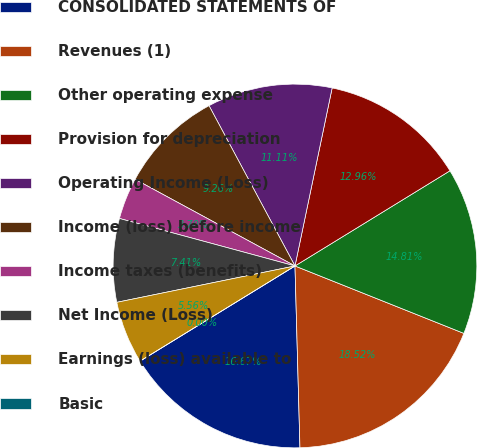<chart> <loc_0><loc_0><loc_500><loc_500><pie_chart><fcel>CONSOLIDATED STATEMENTS OF<fcel>Revenues (1)<fcel>Other operating expense<fcel>Provision for depreciation<fcel>Operating Income (Loss)<fcel>Income (loss) before income<fcel>Income taxes (benefits)<fcel>Net Income (Loss)<fcel>Earnings (loss) available to<fcel>Basic<nl><fcel>16.67%<fcel>18.52%<fcel>14.81%<fcel>12.96%<fcel>11.11%<fcel>9.26%<fcel>3.7%<fcel>7.41%<fcel>5.56%<fcel>0.0%<nl></chart> 